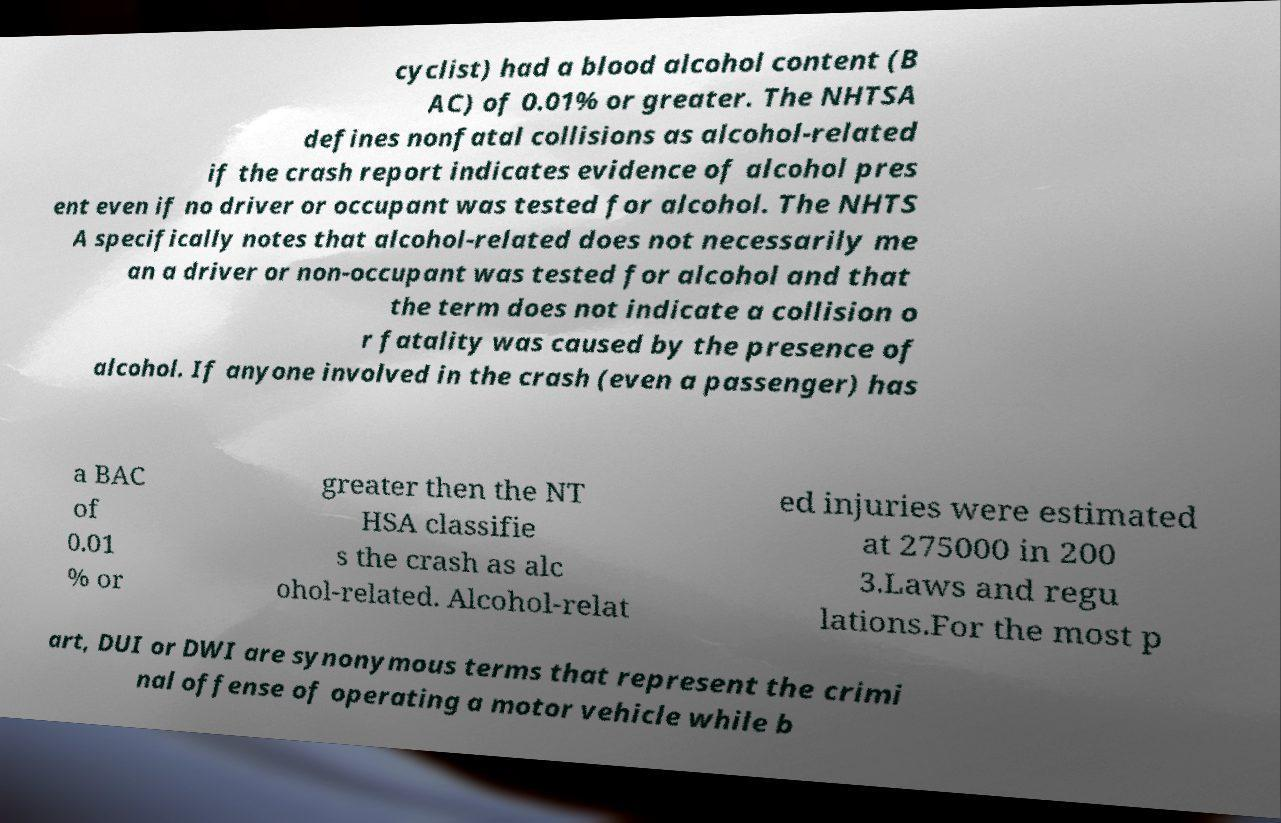Please read and relay the text visible in this image. What does it say? cyclist) had a blood alcohol content (B AC) of 0.01% or greater. The NHTSA defines nonfatal collisions as alcohol-related if the crash report indicates evidence of alcohol pres ent even if no driver or occupant was tested for alcohol. The NHTS A specifically notes that alcohol-related does not necessarily me an a driver or non-occupant was tested for alcohol and that the term does not indicate a collision o r fatality was caused by the presence of alcohol. If anyone involved in the crash (even a passenger) has a BAC of 0.01 % or greater then the NT HSA classifie s the crash as alc ohol-related. Alcohol-relat ed injuries were estimated at 275000 in 200 3.Laws and regu lations.For the most p art, DUI or DWI are synonymous terms that represent the crimi nal offense of operating a motor vehicle while b 